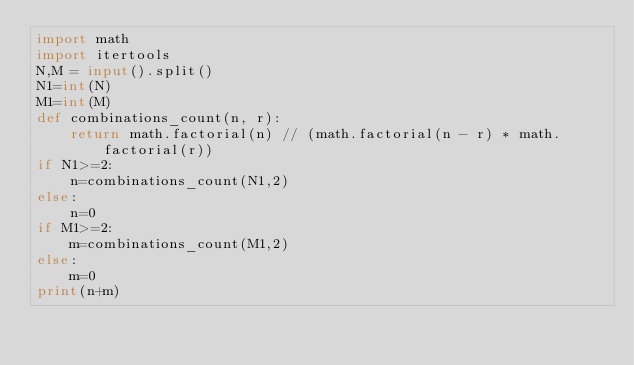Convert code to text. <code><loc_0><loc_0><loc_500><loc_500><_Python_>import math
import itertools
N,M = input().split()
N1=int(N)
M1=int(M)
def combinations_count(n, r):
    return math.factorial(n) // (math.factorial(n - r) * math.factorial(r))
if N1>=2:
    n=combinations_count(N1,2)
else:
    n=0
if M1>=2:
    m=combinations_count(M1,2)
else:
    m=0
print(n+m)
</code> 